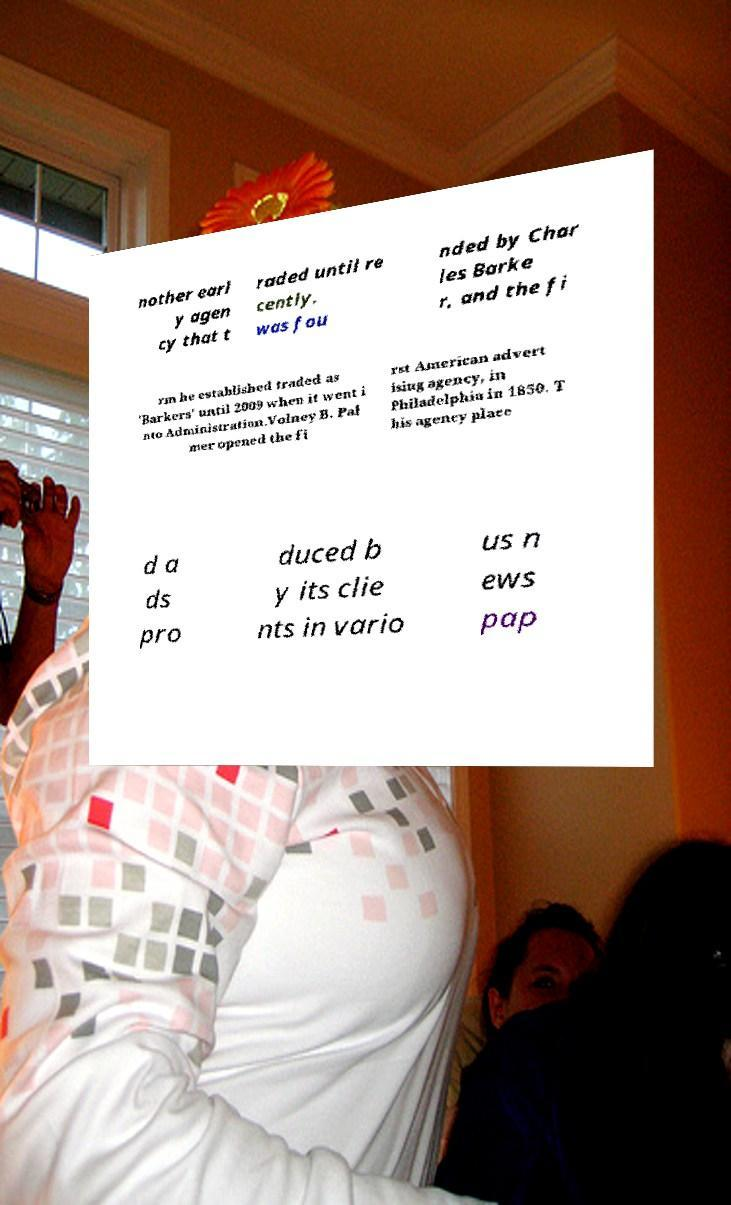There's text embedded in this image that I need extracted. Can you transcribe it verbatim? nother earl y agen cy that t raded until re cently, was fou nded by Char les Barke r, and the fi rm he established traded as 'Barkers' until 2009 when it went i nto Administration.Volney B. Pal mer opened the fi rst American advert ising agency, in Philadelphia in 1850. T his agency place d a ds pro duced b y its clie nts in vario us n ews pap 